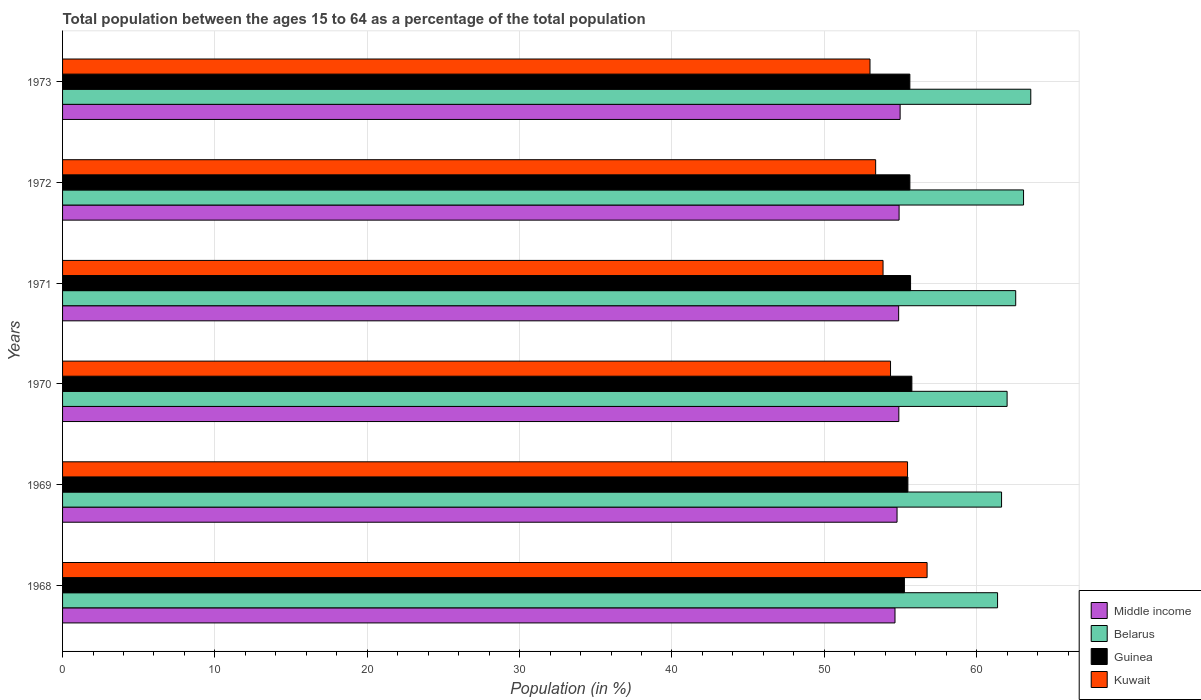How many different coloured bars are there?
Make the answer very short. 4. Are the number of bars on each tick of the Y-axis equal?
Give a very brief answer. Yes. How many bars are there on the 1st tick from the top?
Keep it short and to the point. 4. How many bars are there on the 3rd tick from the bottom?
Give a very brief answer. 4. In how many cases, is the number of bars for a given year not equal to the number of legend labels?
Keep it short and to the point. 0. What is the percentage of the population ages 15 to 64 in Belarus in 1969?
Your answer should be very brief. 61.64. Across all years, what is the maximum percentage of the population ages 15 to 64 in Kuwait?
Keep it short and to the point. 56.75. Across all years, what is the minimum percentage of the population ages 15 to 64 in Middle income?
Your response must be concise. 54.64. In which year was the percentage of the population ages 15 to 64 in Kuwait maximum?
Your response must be concise. 1968. What is the total percentage of the population ages 15 to 64 in Guinea in the graph?
Provide a succinct answer. 333.4. What is the difference between the percentage of the population ages 15 to 64 in Guinea in 1969 and that in 1972?
Provide a short and direct response. -0.13. What is the difference between the percentage of the population ages 15 to 64 in Guinea in 1969 and the percentage of the population ages 15 to 64 in Kuwait in 1972?
Offer a terse response. 2.12. What is the average percentage of the population ages 15 to 64 in Guinea per year?
Give a very brief answer. 55.57. In the year 1968, what is the difference between the percentage of the population ages 15 to 64 in Belarus and percentage of the population ages 15 to 64 in Kuwait?
Your answer should be very brief. 4.63. What is the ratio of the percentage of the population ages 15 to 64 in Middle income in 1969 to that in 1972?
Offer a terse response. 1. Is the percentage of the population ages 15 to 64 in Kuwait in 1968 less than that in 1973?
Your response must be concise. No. What is the difference between the highest and the second highest percentage of the population ages 15 to 64 in Kuwait?
Give a very brief answer. 1.28. What is the difference between the highest and the lowest percentage of the population ages 15 to 64 in Middle income?
Offer a very short reply. 0.34. In how many years, is the percentage of the population ages 15 to 64 in Guinea greater than the average percentage of the population ages 15 to 64 in Guinea taken over all years?
Your answer should be very brief. 4. Is it the case that in every year, the sum of the percentage of the population ages 15 to 64 in Belarus and percentage of the population ages 15 to 64 in Middle income is greater than the sum of percentage of the population ages 15 to 64 in Kuwait and percentage of the population ages 15 to 64 in Guinea?
Give a very brief answer. Yes. What does the 1st bar from the bottom in 1970 represents?
Provide a succinct answer. Middle income. Are all the bars in the graph horizontal?
Your response must be concise. Yes. What is the difference between two consecutive major ticks on the X-axis?
Ensure brevity in your answer.  10. Are the values on the major ticks of X-axis written in scientific E-notation?
Your answer should be compact. No. Does the graph contain grids?
Your answer should be compact. Yes. How many legend labels are there?
Your response must be concise. 4. What is the title of the graph?
Provide a succinct answer. Total population between the ages 15 to 64 as a percentage of the total population. Does "Turkey" appear as one of the legend labels in the graph?
Offer a terse response. No. What is the label or title of the X-axis?
Provide a short and direct response. Population (in %). What is the Population (in %) of Middle income in 1968?
Provide a short and direct response. 54.64. What is the Population (in %) in Belarus in 1968?
Make the answer very short. 61.37. What is the Population (in %) in Guinea in 1968?
Make the answer very short. 55.26. What is the Population (in %) of Kuwait in 1968?
Ensure brevity in your answer.  56.75. What is the Population (in %) of Middle income in 1969?
Your response must be concise. 54.78. What is the Population (in %) in Belarus in 1969?
Ensure brevity in your answer.  61.64. What is the Population (in %) in Guinea in 1969?
Your response must be concise. 55.49. What is the Population (in %) in Kuwait in 1969?
Give a very brief answer. 55.47. What is the Population (in %) of Middle income in 1970?
Your answer should be very brief. 54.89. What is the Population (in %) of Belarus in 1970?
Keep it short and to the point. 62. What is the Population (in %) of Guinea in 1970?
Your response must be concise. 55.75. What is the Population (in %) in Kuwait in 1970?
Your answer should be compact. 54.35. What is the Population (in %) in Middle income in 1971?
Keep it short and to the point. 54.88. What is the Population (in %) in Belarus in 1971?
Offer a very short reply. 62.57. What is the Population (in %) of Guinea in 1971?
Give a very brief answer. 55.66. What is the Population (in %) in Kuwait in 1971?
Make the answer very short. 53.86. What is the Population (in %) in Middle income in 1972?
Offer a terse response. 54.91. What is the Population (in %) in Belarus in 1972?
Provide a succinct answer. 63.08. What is the Population (in %) of Guinea in 1972?
Provide a short and direct response. 55.62. What is the Population (in %) of Kuwait in 1972?
Keep it short and to the point. 53.37. What is the Population (in %) of Middle income in 1973?
Offer a terse response. 54.98. What is the Population (in %) of Belarus in 1973?
Offer a terse response. 63.56. What is the Population (in %) in Guinea in 1973?
Your answer should be very brief. 55.62. What is the Population (in %) in Kuwait in 1973?
Offer a very short reply. 53. Across all years, what is the maximum Population (in %) in Middle income?
Offer a terse response. 54.98. Across all years, what is the maximum Population (in %) of Belarus?
Make the answer very short. 63.56. Across all years, what is the maximum Population (in %) in Guinea?
Give a very brief answer. 55.75. Across all years, what is the maximum Population (in %) of Kuwait?
Keep it short and to the point. 56.75. Across all years, what is the minimum Population (in %) in Middle income?
Make the answer very short. 54.64. Across all years, what is the minimum Population (in %) of Belarus?
Keep it short and to the point. 61.37. Across all years, what is the minimum Population (in %) of Guinea?
Provide a succinct answer. 55.26. Across all years, what is the minimum Population (in %) of Kuwait?
Offer a very short reply. 53. What is the total Population (in %) in Middle income in the graph?
Give a very brief answer. 329.08. What is the total Population (in %) in Belarus in the graph?
Your response must be concise. 374.21. What is the total Population (in %) of Guinea in the graph?
Keep it short and to the point. 333.4. What is the total Population (in %) of Kuwait in the graph?
Give a very brief answer. 326.79. What is the difference between the Population (in %) in Middle income in 1968 and that in 1969?
Provide a succinct answer. -0.14. What is the difference between the Population (in %) of Belarus in 1968 and that in 1969?
Your response must be concise. -0.26. What is the difference between the Population (in %) in Guinea in 1968 and that in 1969?
Make the answer very short. -0.23. What is the difference between the Population (in %) of Kuwait in 1968 and that in 1969?
Your answer should be very brief. 1.28. What is the difference between the Population (in %) of Middle income in 1968 and that in 1970?
Provide a succinct answer. -0.25. What is the difference between the Population (in %) in Belarus in 1968 and that in 1970?
Offer a very short reply. -0.63. What is the difference between the Population (in %) of Guinea in 1968 and that in 1970?
Offer a very short reply. -0.49. What is the difference between the Population (in %) in Kuwait in 1968 and that in 1970?
Give a very brief answer. 2.4. What is the difference between the Population (in %) of Middle income in 1968 and that in 1971?
Provide a succinct answer. -0.24. What is the difference between the Population (in %) of Belarus in 1968 and that in 1971?
Ensure brevity in your answer.  -1.19. What is the difference between the Population (in %) in Guinea in 1968 and that in 1971?
Give a very brief answer. -0.4. What is the difference between the Population (in %) in Kuwait in 1968 and that in 1971?
Provide a short and direct response. 2.89. What is the difference between the Population (in %) of Middle income in 1968 and that in 1972?
Keep it short and to the point. -0.27. What is the difference between the Population (in %) of Belarus in 1968 and that in 1972?
Give a very brief answer. -1.71. What is the difference between the Population (in %) in Guinea in 1968 and that in 1972?
Ensure brevity in your answer.  -0.36. What is the difference between the Population (in %) of Kuwait in 1968 and that in 1972?
Provide a short and direct response. 3.38. What is the difference between the Population (in %) in Middle income in 1968 and that in 1973?
Your response must be concise. -0.34. What is the difference between the Population (in %) in Belarus in 1968 and that in 1973?
Your answer should be compact. -2.18. What is the difference between the Population (in %) of Guinea in 1968 and that in 1973?
Your response must be concise. -0.36. What is the difference between the Population (in %) of Kuwait in 1968 and that in 1973?
Keep it short and to the point. 3.75. What is the difference between the Population (in %) of Middle income in 1969 and that in 1970?
Offer a very short reply. -0.12. What is the difference between the Population (in %) in Belarus in 1969 and that in 1970?
Provide a succinct answer. -0.36. What is the difference between the Population (in %) in Guinea in 1969 and that in 1970?
Provide a succinct answer. -0.26. What is the difference between the Population (in %) in Kuwait in 1969 and that in 1970?
Offer a terse response. 1.12. What is the difference between the Population (in %) in Middle income in 1969 and that in 1971?
Offer a very short reply. -0.1. What is the difference between the Population (in %) in Belarus in 1969 and that in 1971?
Your response must be concise. -0.93. What is the difference between the Population (in %) of Guinea in 1969 and that in 1971?
Your answer should be compact. -0.18. What is the difference between the Population (in %) of Kuwait in 1969 and that in 1971?
Give a very brief answer. 1.61. What is the difference between the Population (in %) in Middle income in 1969 and that in 1972?
Your answer should be very brief. -0.13. What is the difference between the Population (in %) in Belarus in 1969 and that in 1972?
Ensure brevity in your answer.  -1.44. What is the difference between the Population (in %) of Guinea in 1969 and that in 1972?
Give a very brief answer. -0.13. What is the difference between the Population (in %) of Kuwait in 1969 and that in 1972?
Your answer should be compact. 2.09. What is the difference between the Population (in %) of Middle income in 1969 and that in 1973?
Your answer should be compact. -0.2. What is the difference between the Population (in %) in Belarus in 1969 and that in 1973?
Keep it short and to the point. -1.92. What is the difference between the Population (in %) in Guinea in 1969 and that in 1973?
Your answer should be compact. -0.13. What is the difference between the Population (in %) of Kuwait in 1969 and that in 1973?
Your response must be concise. 2.46. What is the difference between the Population (in %) in Middle income in 1970 and that in 1971?
Keep it short and to the point. 0.01. What is the difference between the Population (in %) in Belarus in 1970 and that in 1971?
Ensure brevity in your answer.  -0.56. What is the difference between the Population (in %) in Guinea in 1970 and that in 1971?
Keep it short and to the point. 0.09. What is the difference between the Population (in %) in Kuwait in 1970 and that in 1971?
Your answer should be compact. 0.49. What is the difference between the Population (in %) in Middle income in 1970 and that in 1972?
Provide a short and direct response. -0.02. What is the difference between the Population (in %) of Belarus in 1970 and that in 1972?
Keep it short and to the point. -1.08. What is the difference between the Population (in %) of Guinea in 1970 and that in 1972?
Your answer should be very brief. 0.13. What is the difference between the Population (in %) of Kuwait in 1970 and that in 1972?
Provide a short and direct response. 0.98. What is the difference between the Population (in %) in Middle income in 1970 and that in 1973?
Give a very brief answer. -0.08. What is the difference between the Population (in %) of Belarus in 1970 and that in 1973?
Give a very brief answer. -1.55. What is the difference between the Population (in %) in Guinea in 1970 and that in 1973?
Your answer should be compact. 0.13. What is the difference between the Population (in %) in Kuwait in 1970 and that in 1973?
Ensure brevity in your answer.  1.35. What is the difference between the Population (in %) of Middle income in 1971 and that in 1972?
Offer a terse response. -0.03. What is the difference between the Population (in %) in Belarus in 1971 and that in 1972?
Give a very brief answer. -0.51. What is the difference between the Population (in %) in Guinea in 1971 and that in 1972?
Offer a terse response. 0.04. What is the difference between the Population (in %) of Kuwait in 1971 and that in 1972?
Make the answer very short. 0.49. What is the difference between the Population (in %) in Middle income in 1971 and that in 1973?
Provide a succinct answer. -0.1. What is the difference between the Population (in %) in Belarus in 1971 and that in 1973?
Provide a succinct answer. -0.99. What is the difference between the Population (in %) in Guinea in 1971 and that in 1973?
Ensure brevity in your answer.  0.05. What is the difference between the Population (in %) in Kuwait in 1971 and that in 1973?
Your answer should be very brief. 0.86. What is the difference between the Population (in %) in Middle income in 1972 and that in 1973?
Offer a very short reply. -0.07. What is the difference between the Population (in %) of Belarus in 1972 and that in 1973?
Provide a short and direct response. -0.48. What is the difference between the Population (in %) in Guinea in 1972 and that in 1973?
Provide a short and direct response. 0. What is the difference between the Population (in %) of Kuwait in 1972 and that in 1973?
Your answer should be very brief. 0.37. What is the difference between the Population (in %) in Middle income in 1968 and the Population (in %) in Belarus in 1969?
Offer a very short reply. -7. What is the difference between the Population (in %) of Middle income in 1968 and the Population (in %) of Guinea in 1969?
Offer a very short reply. -0.85. What is the difference between the Population (in %) in Middle income in 1968 and the Population (in %) in Kuwait in 1969?
Your answer should be compact. -0.82. What is the difference between the Population (in %) in Belarus in 1968 and the Population (in %) in Guinea in 1969?
Provide a short and direct response. 5.89. What is the difference between the Population (in %) in Belarus in 1968 and the Population (in %) in Kuwait in 1969?
Keep it short and to the point. 5.91. What is the difference between the Population (in %) in Guinea in 1968 and the Population (in %) in Kuwait in 1969?
Offer a very short reply. -0.21. What is the difference between the Population (in %) in Middle income in 1968 and the Population (in %) in Belarus in 1970?
Keep it short and to the point. -7.36. What is the difference between the Population (in %) of Middle income in 1968 and the Population (in %) of Guinea in 1970?
Offer a terse response. -1.11. What is the difference between the Population (in %) in Middle income in 1968 and the Population (in %) in Kuwait in 1970?
Ensure brevity in your answer.  0.29. What is the difference between the Population (in %) of Belarus in 1968 and the Population (in %) of Guinea in 1970?
Offer a very short reply. 5.62. What is the difference between the Population (in %) of Belarus in 1968 and the Population (in %) of Kuwait in 1970?
Provide a short and direct response. 7.03. What is the difference between the Population (in %) of Guinea in 1968 and the Population (in %) of Kuwait in 1970?
Give a very brief answer. 0.91. What is the difference between the Population (in %) in Middle income in 1968 and the Population (in %) in Belarus in 1971?
Provide a succinct answer. -7.92. What is the difference between the Population (in %) in Middle income in 1968 and the Population (in %) in Guinea in 1971?
Offer a very short reply. -1.02. What is the difference between the Population (in %) in Middle income in 1968 and the Population (in %) in Kuwait in 1971?
Make the answer very short. 0.78. What is the difference between the Population (in %) in Belarus in 1968 and the Population (in %) in Guinea in 1971?
Give a very brief answer. 5.71. What is the difference between the Population (in %) of Belarus in 1968 and the Population (in %) of Kuwait in 1971?
Give a very brief answer. 7.52. What is the difference between the Population (in %) of Guinea in 1968 and the Population (in %) of Kuwait in 1971?
Your answer should be very brief. 1.4. What is the difference between the Population (in %) of Middle income in 1968 and the Population (in %) of Belarus in 1972?
Your response must be concise. -8.44. What is the difference between the Population (in %) of Middle income in 1968 and the Population (in %) of Guinea in 1972?
Keep it short and to the point. -0.98. What is the difference between the Population (in %) of Middle income in 1968 and the Population (in %) of Kuwait in 1972?
Your response must be concise. 1.27. What is the difference between the Population (in %) of Belarus in 1968 and the Population (in %) of Guinea in 1972?
Your response must be concise. 5.75. What is the difference between the Population (in %) of Belarus in 1968 and the Population (in %) of Kuwait in 1972?
Your response must be concise. 8. What is the difference between the Population (in %) of Guinea in 1968 and the Population (in %) of Kuwait in 1972?
Offer a terse response. 1.89. What is the difference between the Population (in %) of Middle income in 1968 and the Population (in %) of Belarus in 1973?
Your answer should be very brief. -8.91. What is the difference between the Population (in %) in Middle income in 1968 and the Population (in %) in Guinea in 1973?
Your response must be concise. -0.98. What is the difference between the Population (in %) in Middle income in 1968 and the Population (in %) in Kuwait in 1973?
Provide a succinct answer. 1.64. What is the difference between the Population (in %) in Belarus in 1968 and the Population (in %) in Guinea in 1973?
Give a very brief answer. 5.76. What is the difference between the Population (in %) in Belarus in 1968 and the Population (in %) in Kuwait in 1973?
Give a very brief answer. 8.37. What is the difference between the Population (in %) in Guinea in 1968 and the Population (in %) in Kuwait in 1973?
Your response must be concise. 2.26. What is the difference between the Population (in %) in Middle income in 1969 and the Population (in %) in Belarus in 1970?
Offer a terse response. -7.22. What is the difference between the Population (in %) of Middle income in 1969 and the Population (in %) of Guinea in 1970?
Provide a succinct answer. -0.97. What is the difference between the Population (in %) in Middle income in 1969 and the Population (in %) in Kuwait in 1970?
Ensure brevity in your answer.  0.43. What is the difference between the Population (in %) in Belarus in 1969 and the Population (in %) in Guinea in 1970?
Ensure brevity in your answer.  5.89. What is the difference between the Population (in %) of Belarus in 1969 and the Population (in %) of Kuwait in 1970?
Offer a terse response. 7.29. What is the difference between the Population (in %) in Guinea in 1969 and the Population (in %) in Kuwait in 1970?
Provide a short and direct response. 1.14. What is the difference between the Population (in %) in Middle income in 1969 and the Population (in %) in Belarus in 1971?
Your answer should be compact. -7.79. What is the difference between the Population (in %) in Middle income in 1969 and the Population (in %) in Guinea in 1971?
Offer a very short reply. -0.89. What is the difference between the Population (in %) in Middle income in 1969 and the Population (in %) in Kuwait in 1971?
Make the answer very short. 0.92. What is the difference between the Population (in %) in Belarus in 1969 and the Population (in %) in Guinea in 1971?
Provide a succinct answer. 5.97. What is the difference between the Population (in %) of Belarus in 1969 and the Population (in %) of Kuwait in 1971?
Make the answer very short. 7.78. What is the difference between the Population (in %) of Guinea in 1969 and the Population (in %) of Kuwait in 1971?
Your response must be concise. 1.63. What is the difference between the Population (in %) in Middle income in 1969 and the Population (in %) in Belarus in 1972?
Offer a very short reply. -8.3. What is the difference between the Population (in %) in Middle income in 1969 and the Population (in %) in Guinea in 1972?
Keep it short and to the point. -0.84. What is the difference between the Population (in %) in Middle income in 1969 and the Population (in %) in Kuwait in 1972?
Provide a succinct answer. 1.4. What is the difference between the Population (in %) of Belarus in 1969 and the Population (in %) of Guinea in 1972?
Your answer should be compact. 6.02. What is the difference between the Population (in %) in Belarus in 1969 and the Population (in %) in Kuwait in 1972?
Offer a terse response. 8.26. What is the difference between the Population (in %) in Guinea in 1969 and the Population (in %) in Kuwait in 1972?
Your response must be concise. 2.12. What is the difference between the Population (in %) of Middle income in 1969 and the Population (in %) of Belarus in 1973?
Offer a terse response. -8.78. What is the difference between the Population (in %) of Middle income in 1969 and the Population (in %) of Guinea in 1973?
Offer a terse response. -0.84. What is the difference between the Population (in %) in Middle income in 1969 and the Population (in %) in Kuwait in 1973?
Provide a succinct answer. 1.78. What is the difference between the Population (in %) in Belarus in 1969 and the Population (in %) in Guinea in 1973?
Offer a very short reply. 6.02. What is the difference between the Population (in %) of Belarus in 1969 and the Population (in %) of Kuwait in 1973?
Ensure brevity in your answer.  8.64. What is the difference between the Population (in %) in Guinea in 1969 and the Population (in %) in Kuwait in 1973?
Keep it short and to the point. 2.49. What is the difference between the Population (in %) of Middle income in 1970 and the Population (in %) of Belarus in 1971?
Keep it short and to the point. -7.67. What is the difference between the Population (in %) in Middle income in 1970 and the Population (in %) in Guinea in 1971?
Offer a terse response. -0.77. What is the difference between the Population (in %) of Middle income in 1970 and the Population (in %) of Kuwait in 1971?
Keep it short and to the point. 1.04. What is the difference between the Population (in %) in Belarus in 1970 and the Population (in %) in Guinea in 1971?
Your answer should be very brief. 6.34. What is the difference between the Population (in %) of Belarus in 1970 and the Population (in %) of Kuwait in 1971?
Provide a short and direct response. 8.14. What is the difference between the Population (in %) in Guinea in 1970 and the Population (in %) in Kuwait in 1971?
Ensure brevity in your answer.  1.89. What is the difference between the Population (in %) in Middle income in 1970 and the Population (in %) in Belarus in 1972?
Ensure brevity in your answer.  -8.19. What is the difference between the Population (in %) in Middle income in 1970 and the Population (in %) in Guinea in 1972?
Your answer should be very brief. -0.73. What is the difference between the Population (in %) of Middle income in 1970 and the Population (in %) of Kuwait in 1972?
Provide a short and direct response. 1.52. What is the difference between the Population (in %) of Belarus in 1970 and the Population (in %) of Guinea in 1972?
Provide a short and direct response. 6.38. What is the difference between the Population (in %) of Belarus in 1970 and the Population (in %) of Kuwait in 1972?
Provide a short and direct response. 8.63. What is the difference between the Population (in %) in Guinea in 1970 and the Population (in %) in Kuwait in 1972?
Provide a succinct answer. 2.38. What is the difference between the Population (in %) of Middle income in 1970 and the Population (in %) of Belarus in 1973?
Your answer should be very brief. -8.66. What is the difference between the Population (in %) in Middle income in 1970 and the Population (in %) in Guinea in 1973?
Ensure brevity in your answer.  -0.72. What is the difference between the Population (in %) in Middle income in 1970 and the Population (in %) in Kuwait in 1973?
Keep it short and to the point. 1.89. What is the difference between the Population (in %) in Belarus in 1970 and the Population (in %) in Guinea in 1973?
Offer a terse response. 6.38. What is the difference between the Population (in %) in Guinea in 1970 and the Population (in %) in Kuwait in 1973?
Ensure brevity in your answer.  2.75. What is the difference between the Population (in %) in Middle income in 1971 and the Population (in %) in Belarus in 1972?
Keep it short and to the point. -8.2. What is the difference between the Population (in %) of Middle income in 1971 and the Population (in %) of Guinea in 1972?
Provide a short and direct response. -0.74. What is the difference between the Population (in %) in Middle income in 1971 and the Population (in %) in Kuwait in 1972?
Offer a terse response. 1.51. What is the difference between the Population (in %) of Belarus in 1971 and the Population (in %) of Guinea in 1972?
Your response must be concise. 6.95. What is the difference between the Population (in %) in Belarus in 1971 and the Population (in %) in Kuwait in 1972?
Make the answer very short. 9.19. What is the difference between the Population (in %) of Guinea in 1971 and the Population (in %) of Kuwait in 1972?
Make the answer very short. 2.29. What is the difference between the Population (in %) in Middle income in 1971 and the Population (in %) in Belarus in 1973?
Offer a terse response. -8.67. What is the difference between the Population (in %) in Middle income in 1971 and the Population (in %) in Guinea in 1973?
Provide a succinct answer. -0.74. What is the difference between the Population (in %) of Middle income in 1971 and the Population (in %) of Kuwait in 1973?
Offer a terse response. 1.88. What is the difference between the Population (in %) in Belarus in 1971 and the Population (in %) in Guinea in 1973?
Your response must be concise. 6.95. What is the difference between the Population (in %) of Belarus in 1971 and the Population (in %) of Kuwait in 1973?
Provide a succinct answer. 9.56. What is the difference between the Population (in %) in Guinea in 1971 and the Population (in %) in Kuwait in 1973?
Offer a very short reply. 2.66. What is the difference between the Population (in %) of Middle income in 1972 and the Population (in %) of Belarus in 1973?
Make the answer very short. -8.64. What is the difference between the Population (in %) of Middle income in 1972 and the Population (in %) of Guinea in 1973?
Give a very brief answer. -0.71. What is the difference between the Population (in %) in Middle income in 1972 and the Population (in %) in Kuwait in 1973?
Your response must be concise. 1.91. What is the difference between the Population (in %) of Belarus in 1972 and the Population (in %) of Guinea in 1973?
Offer a very short reply. 7.46. What is the difference between the Population (in %) in Belarus in 1972 and the Population (in %) in Kuwait in 1973?
Give a very brief answer. 10.08. What is the difference between the Population (in %) of Guinea in 1972 and the Population (in %) of Kuwait in 1973?
Your response must be concise. 2.62. What is the average Population (in %) in Middle income per year?
Offer a terse response. 54.85. What is the average Population (in %) in Belarus per year?
Your response must be concise. 62.37. What is the average Population (in %) in Guinea per year?
Your response must be concise. 55.57. What is the average Population (in %) in Kuwait per year?
Your answer should be compact. 54.47. In the year 1968, what is the difference between the Population (in %) in Middle income and Population (in %) in Belarus?
Offer a terse response. -6.73. In the year 1968, what is the difference between the Population (in %) in Middle income and Population (in %) in Guinea?
Your response must be concise. -0.62. In the year 1968, what is the difference between the Population (in %) in Middle income and Population (in %) in Kuwait?
Make the answer very short. -2.11. In the year 1968, what is the difference between the Population (in %) of Belarus and Population (in %) of Guinea?
Make the answer very short. 6.12. In the year 1968, what is the difference between the Population (in %) of Belarus and Population (in %) of Kuwait?
Your response must be concise. 4.63. In the year 1968, what is the difference between the Population (in %) of Guinea and Population (in %) of Kuwait?
Keep it short and to the point. -1.49. In the year 1969, what is the difference between the Population (in %) of Middle income and Population (in %) of Belarus?
Provide a succinct answer. -6.86. In the year 1969, what is the difference between the Population (in %) of Middle income and Population (in %) of Guinea?
Ensure brevity in your answer.  -0.71. In the year 1969, what is the difference between the Population (in %) in Middle income and Population (in %) in Kuwait?
Ensure brevity in your answer.  -0.69. In the year 1969, what is the difference between the Population (in %) in Belarus and Population (in %) in Guinea?
Offer a very short reply. 6.15. In the year 1969, what is the difference between the Population (in %) in Belarus and Population (in %) in Kuwait?
Offer a very short reply. 6.17. In the year 1969, what is the difference between the Population (in %) of Guinea and Population (in %) of Kuwait?
Make the answer very short. 0.02. In the year 1970, what is the difference between the Population (in %) in Middle income and Population (in %) in Belarus?
Offer a very short reply. -7.11. In the year 1970, what is the difference between the Population (in %) in Middle income and Population (in %) in Guinea?
Offer a terse response. -0.86. In the year 1970, what is the difference between the Population (in %) of Middle income and Population (in %) of Kuwait?
Keep it short and to the point. 0.54. In the year 1970, what is the difference between the Population (in %) in Belarus and Population (in %) in Guinea?
Provide a short and direct response. 6.25. In the year 1970, what is the difference between the Population (in %) in Belarus and Population (in %) in Kuwait?
Provide a short and direct response. 7.65. In the year 1970, what is the difference between the Population (in %) in Guinea and Population (in %) in Kuwait?
Keep it short and to the point. 1.4. In the year 1971, what is the difference between the Population (in %) of Middle income and Population (in %) of Belarus?
Your answer should be very brief. -7.68. In the year 1971, what is the difference between the Population (in %) of Middle income and Population (in %) of Guinea?
Your response must be concise. -0.78. In the year 1971, what is the difference between the Population (in %) in Middle income and Population (in %) in Kuwait?
Offer a terse response. 1.02. In the year 1971, what is the difference between the Population (in %) in Belarus and Population (in %) in Guinea?
Your answer should be very brief. 6.9. In the year 1971, what is the difference between the Population (in %) of Belarus and Population (in %) of Kuwait?
Provide a succinct answer. 8.71. In the year 1971, what is the difference between the Population (in %) in Guinea and Population (in %) in Kuwait?
Offer a very short reply. 1.81. In the year 1972, what is the difference between the Population (in %) in Middle income and Population (in %) in Belarus?
Make the answer very short. -8.17. In the year 1972, what is the difference between the Population (in %) in Middle income and Population (in %) in Guinea?
Provide a short and direct response. -0.71. In the year 1972, what is the difference between the Population (in %) of Middle income and Population (in %) of Kuwait?
Offer a terse response. 1.54. In the year 1972, what is the difference between the Population (in %) of Belarus and Population (in %) of Guinea?
Provide a succinct answer. 7.46. In the year 1972, what is the difference between the Population (in %) in Belarus and Population (in %) in Kuwait?
Give a very brief answer. 9.71. In the year 1972, what is the difference between the Population (in %) in Guinea and Population (in %) in Kuwait?
Make the answer very short. 2.25. In the year 1973, what is the difference between the Population (in %) of Middle income and Population (in %) of Belarus?
Ensure brevity in your answer.  -8.58. In the year 1973, what is the difference between the Population (in %) of Middle income and Population (in %) of Guinea?
Give a very brief answer. -0.64. In the year 1973, what is the difference between the Population (in %) in Middle income and Population (in %) in Kuwait?
Your response must be concise. 1.98. In the year 1973, what is the difference between the Population (in %) of Belarus and Population (in %) of Guinea?
Provide a short and direct response. 7.94. In the year 1973, what is the difference between the Population (in %) in Belarus and Population (in %) in Kuwait?
Ensure brevity in your answer.  10.55. In the year 1973, what is the difference between the Population (in %) of Guinea and Population (in %) of Kuwait?
Your answer should be very brief. 2.62. What is the ratio of the Population (in %) of Middle income in 1968 to that in 1969?
Provide a succinct answer. 1. What is the ratio of the Population (in %) in Kuwait in 1968 to that in 1969?
Your response must be concise. 1.02. What is the ratio of the Population (in %) in Kuwait in 1968 to that in 1970?
Keep it short and to the point. 1.04. What is the ratio of the Population (in %) of Belarus in 1968 to that in 1971?
Make the answer very short. 0.98. What is the ratio of the Population (in %) of Kuwait in 1968 to that in 1971?
Make the answer very short. 1.05. What is the ratio of the Population (in %) of Middle income in 1968 to that in 1972?
Ensure brevity in your answer.  1. What is the ratio of the Population (in %) in Belarus in 1968 to that in 1972?
Provide a succinct answer. 0.97. What is the ratio of the Population (in %) in Kuwait in 1968 to that in 1972?
Give a very brief answer. 1.06. What is the ratio of the Population (in %) in Belarus in 1968 to that in 1973?
Make the answer very short. 0.97. What is the ratio of the Population (in %) of Guinea in 1968 to that in 1973?
Your answer should be very brief. 0.99. What is the ratio of the Population (in %) of Kuwait in 1968 to that in 1973?
Keep it short and to the point. 1.07. What is the ratio of the Population (in %) of Kuwait in 1969 to that in 1970?
Your answer should be compact. 1.02. What is the ratio of the Population (in %) of Belarus in 1969 to that in 1971?
Offer a very short reply. 0.99. What is the ratio of the Population (in %) in Kuwait in 1969 to that in 1971?
Provide a succinct answer. 1.03. What is the ratio of the Population (in %) of Belarus in 1969 to that in 1972?
Keep it short and to the point. 0.98. What is the ratio of the Population (in %) in Guinea in 1969 to that in 1972?
Provide a short and direct response. 1. What is the ratio of the Population (in %) of Kuwait in 1969 to that in 1972?
Provide a short and direct response. 1.04. What is the ratio of the Population (in %) in Middle income in 1969 to that in 1973?
Provide a succinct answer. 1. What is the ratio of the Population (in %) in Belarus in 1969 to that in 1973?
Keep it short and to the point. 0.97. What is the ratio of the Population (in %) of Kuwait in 1969 to that in 1973?
Offer a very short reply. 1.05. What is the ratio of the Population (in %) of Guinea in 1970 to that in 1971?
Offer a very short reply. 1. What is the ratio of the Population (in %) in Kuwait in 1970 to that in 1971?
Your answer should be compact. 1.01. What is the ratio of the Population (in %) in Middle income in 1970 to that in 1972?
Make the answer very short. 1. What is the ratio of the Population (in %) in Belarus in 1970 to that in 1972?
Provide a short and direct response. 0.98. What is the ratio of the Population (in %) of Guinea in 1970 to that in 1972?
Provide a short and direct response. 1. What is the ratio of the Population (in %) in Kuwait in 1970 to that in 1972?
Offer a terse response. 1.02. What is the ratio of the Population (in %) in Middle income in 1970 to that in 1973?
Offer a very short reply. 1. What is the ratio of the Population (in %) of Belarus in 1970 to that in 1973?
Provide a succinct answer. 0.98. What is the ratio of the Population (in %) of Guinea in 1970 to that in 1973?
Provide a short and direct response. 1. What is the ratio of the Population (in %) in Kuwait in 1970 to that in 1973?
Make the answer very short. 1.03. What is the ratio of the Population (in %) in Middle income in 1971 to that in 1972?
Offer a terse response. 1. What is the ratio of the Population (in %) of Kuwait in 1971 to that in 1972?
Your answer should be compact. 1.01. What is the ratio of the Population (in %) of Middle income in 1971 to that in 1973?
Keep it short and to the point. 1. What is the ratio of the Population (in %) of Belarus in 1971 to that in 1973?
Your answer should be compact. 0.98. What is the ratio of the Population (in %) in Kuwait in 1971 to that in 1973?
Your response must be concise. 1.02. What is the ratio of the Population (in %) in Belarus in 1972 to that in 1973?
Provide a short and direct response. 0.99. What is the difference between the highest and the second highest Population (in %) of Middle income?
Your response must be concise. 0.07. What is the difference between the highest and the second highest Population (in %) of Belarus?
Ensure brevity in your answer.  0.48. What is the difference between the highest and the second highest Population (in %) of Guinea?
Offer a very short reply. 0.09. What is the difference between the highest and the second highest Population (in %) of Kuwait?
Make the answer very short. 1.28. What is the difference between the highest and the lowest Population (in %) of Middle income?
Provide a succinct answer. 0.34. What is the difference between the highest and the lowest Population (in %) of Belarus?
Your answer should be very brief. 2.18. What is the difference between the highest and the lowest Population (in %) of Guinea?
Provide a short and direct response. 0.49. What is the difference between the highest and the lowest Population (in %) of Kuwait?
Offer a terse response. 3.75. 